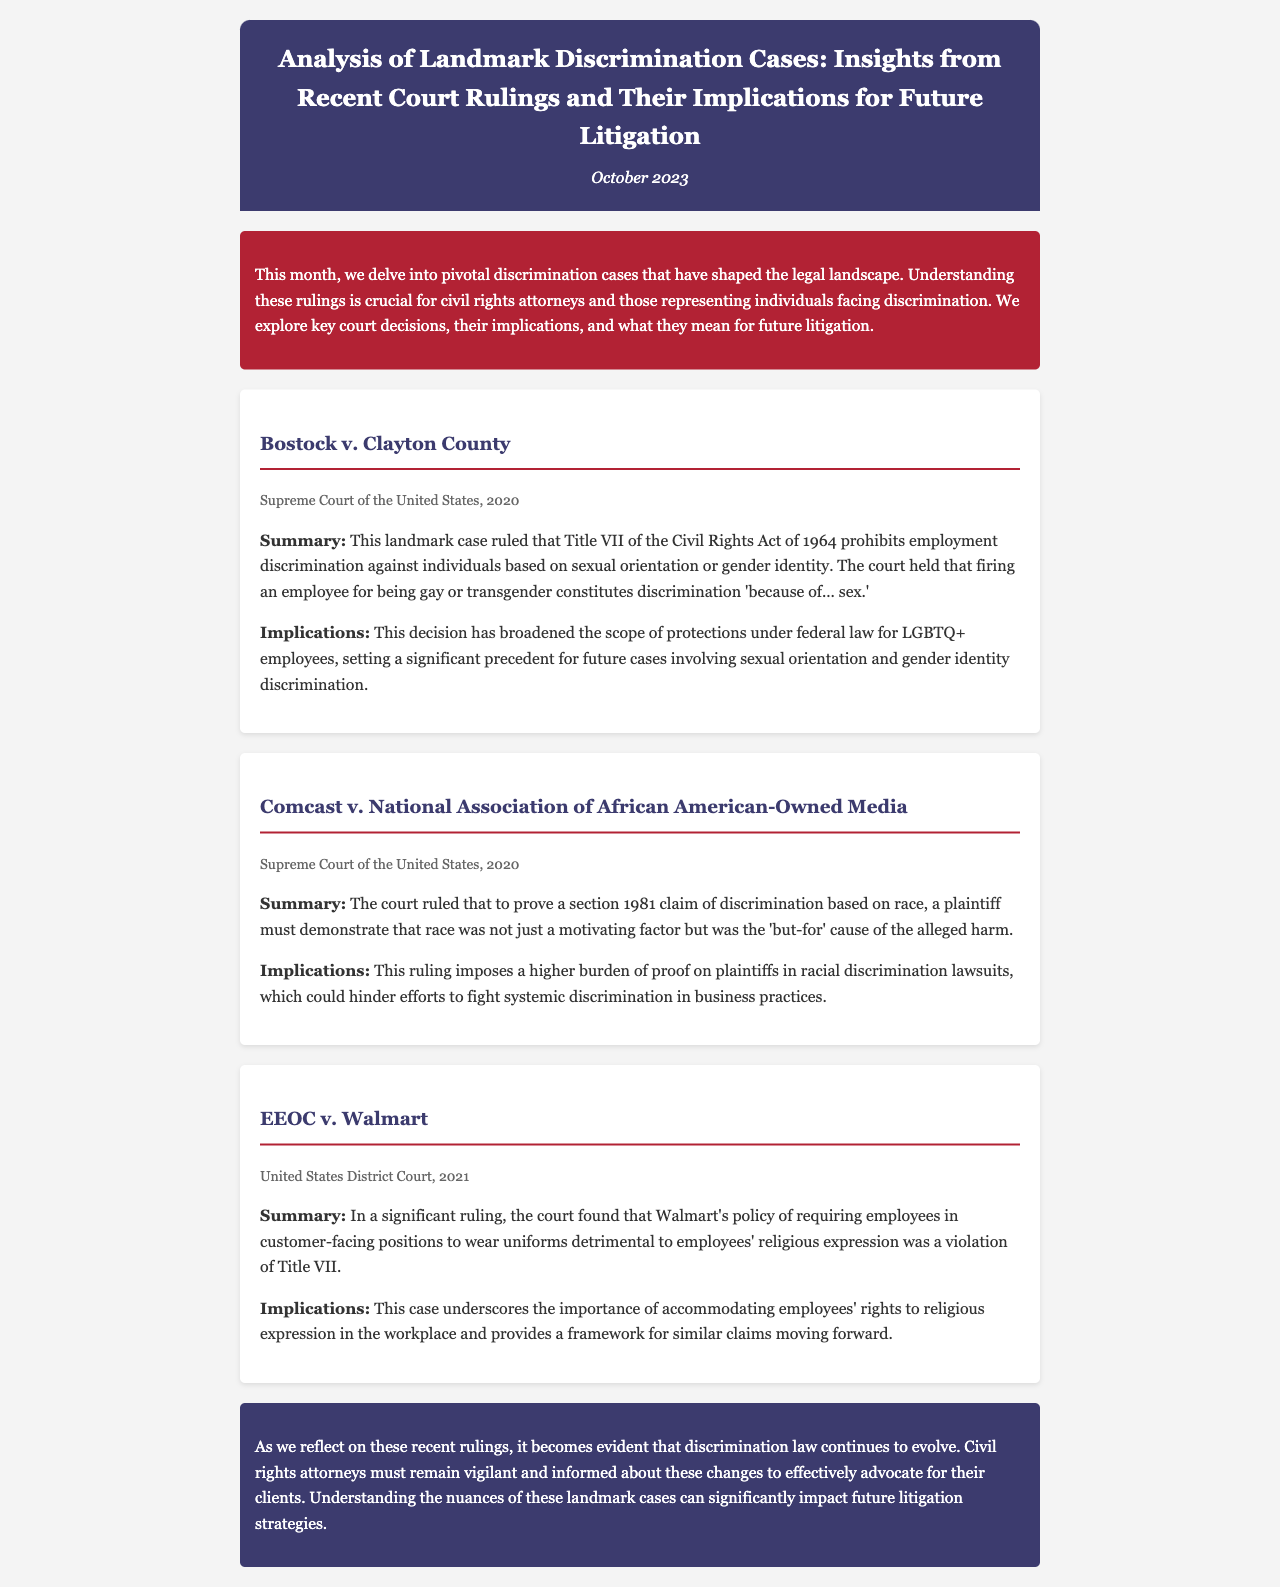What is the title of the newsletter? The title is given at the top of the document, indicating the main focus of the content.
Answer: Analysis of Landmark Discrimination Cases: Insights from Recent Court Rulings and Their Implications for Future Litigation What is the publication date of the newsletter? The publication date is stated in the header of the document.
Answer: October 2023 Which case was decided by the Supreme Court in 2020 regarding employment discrimination? This question asks for the specific case mentioned under the Supreme Court ruling section.
Answer: Bostock v. Clayton County What does Title VII of the Civil Rights Act of 1964 prohibit? This asks for the main focus of the Bostock case regarding discrimination.
Answer: Employment discrimination based on sexual orientation or gender identity In the Comcast v. National Association of African American-Owned Media case, what must a plaintiff prove regarding race? This question inquires about the legal standard established in the Comcast case description.
Answer: Race was the 'but-for' cause of the alleged harm What was the significant ruling in EEOC v. Walmart? This question seeks to summarize the outcome regarding Walmart's policy.
Answer: Violation of Title VII due to harmful uniform policy on religious expression What type of law does the newsletter focus on? The newsletter discusses a specific concept that the mentioned cases and rulings fall under.
Answer: Discrimination law What should civil rights attorneys do in light of recent rulings? This explores the advice or actions recommended in the conclusion of the newsletter.
Answer: Remain vigilant and informed about changes 